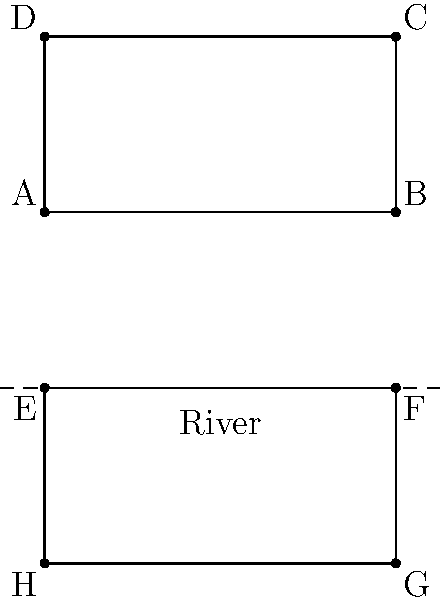In a proposed urban development project, an architect wants to create a balanced cityscape by reflecting a building design across a river. The original building is represented by rectangle ABCD, and its reflection is represented by rectangle EFGH. If the coordinates of point A are (0,0) and point C are (4,2), what is the equation of the line of reflection (i.e., the river)? To find the equation of the line of reflection, we'll follow these steps:

1) First, we need to identify that the line of reflection is the river, which appears to be halfway between the two rectangles.

2) The y-coordinate of this line can be found by taking the average of the y-coordinates of corresponding points in the original and reflected shapes. Let's use points A and E:

   y-coordinate of A: 0
   y-coordinate of E: -2
   Average: (0 + (-2)) / 2 = -1

3) This means the equation of the line will be in the form y = -1.

4) In general, the equation of a horizontal line is y = k, where k is the y-intercept.

5) Therefore, the equation of the line of reflection (the river) is y = -1.

This line represents the axis of symmetry for the reflection transformation between the original building ABCD and its reflection EFGH.
Answer: y = -1 